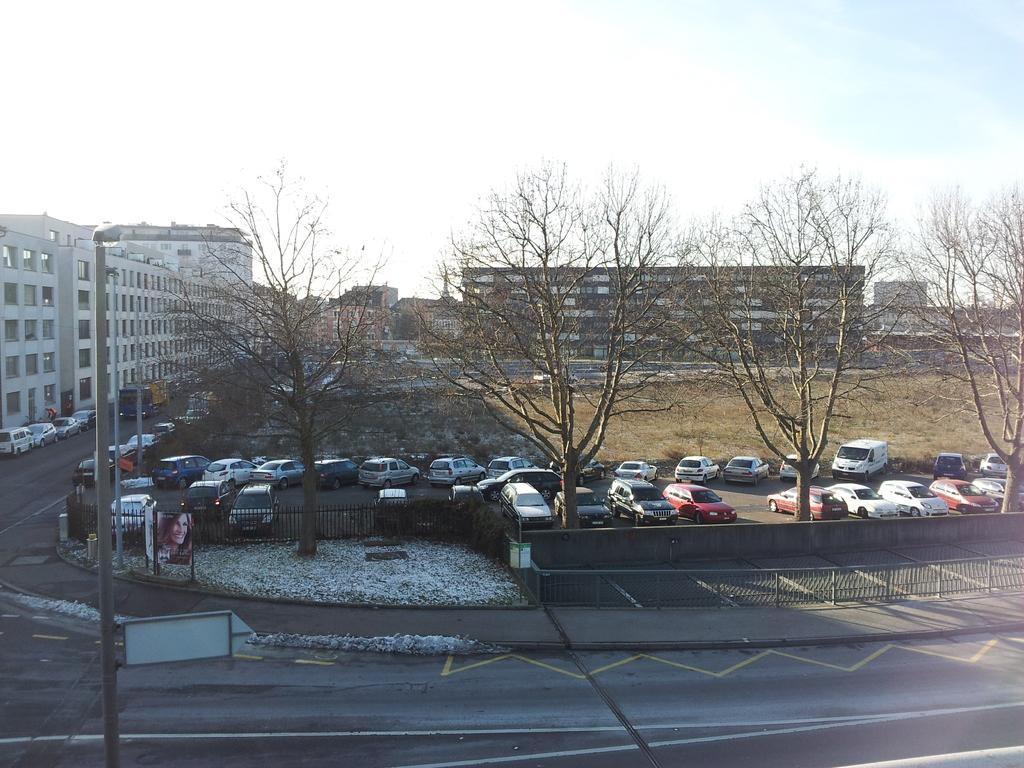Could you give a brief overview of what you see in this image? In this image we can see sky with clouds, poles, fences, snow, trees, motor vehicles on the ground and advertisement boards. 